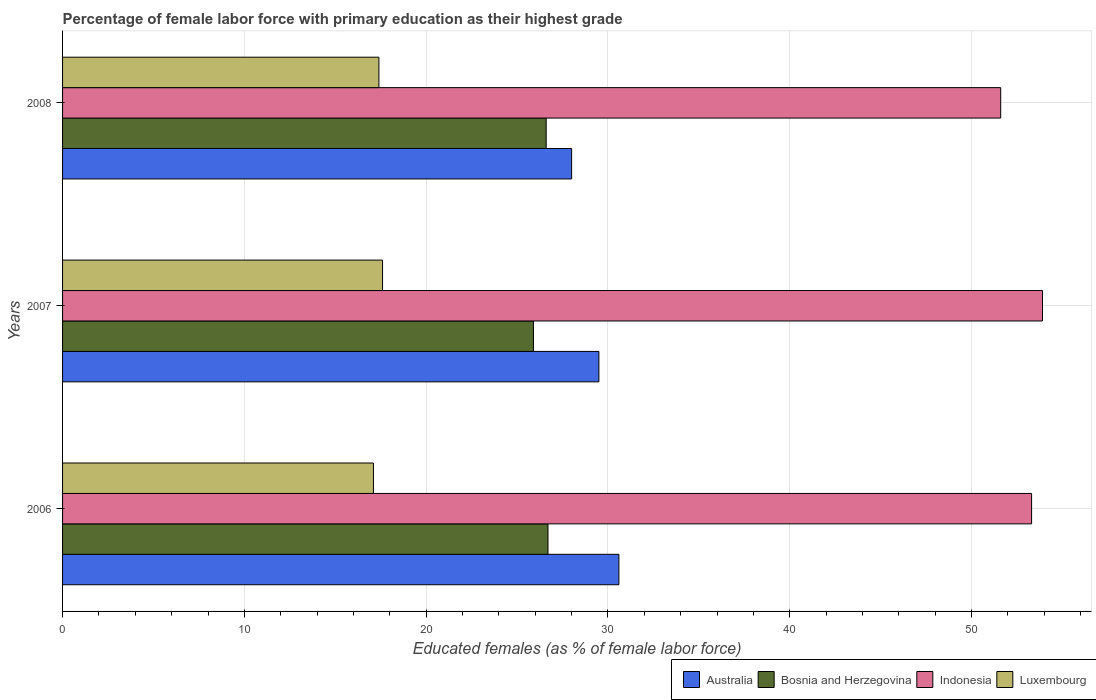How many groups of bars are there?
Ensure brevity in your answer.  3. Are the number of bars on each tick of the Y-axis equal?
Your answer should be compact. Yes. How many bars are there on the 1st tick from the top?
Your answer should be compact. 4. What is the label of the 1st group of bars from the top?
Offer a terse response. 2008. What is the percentage of female labor force with primary education in Indonesia in 2006?
Keep it short and to the point. 53.3. Across all years, what is the maximum percentage of female labor force with primary education in Australia?
Your answer should be very brief. 30.6. Across all years, what is the minimum percentage of female labor force with primary education in Bosnia and Herzegovina?
Give a very brief answer. 25.9. What is the total percentage of female labor force with primary education in Luxembourg in the graph?
Provide a short and direct response. 52.1. What is the difference between the percentage of female labor force with primary education in Luxembourg in 2006 and the percentage of female labor force with primary education in Bosnia and Herzegovina in 2007?
Offer a very short reply. -8.8. What is the average percentage of female labor force with primary education in Bosnia and Herzegovina per year?
Provide a succinct answer. 26.4. In the year 2007, what is the difference between the percentage of female labor force with primary education in Indonesia and percentage of female labor force with primary education in Bosnia and Herzegovina?
Give a very brief answer. 28. In how many years, is the percentage of female labor force with primary education in Bosnia and Herzegovina greater than 10 %?
Provide a succinct answer. 3. What is the ratio of the percentage of female labor force with primary education in Indonesia in 2006 to that in 2008?
Ensure brevity in your answer.  1.03. Is the difference between the percentage of female labor force with primary education in Indonesia in 2006 and 2008 greater than the difference between the percentage of female labor force with primary education in Bosnia and Herzegovina in 2006 and 2008?
Your answer should be very brief. Yes. What is the difference between the highest and the second highest percentage of female labor force with primary education in Bosnia and Herzegovina?
Your answer should be compact. 0.1. What is the difference between the highest and the lowest percentage of female labor force with primary education in Indonesia?
Provide a succinct answer. 2.3. Is it the case that in every year, the sum of the percentage of female labor force with primary education in Luxembourg and percentage of female labor force with primary education in Australia is greater than the sum of percentage of female labor force with primary education in Bosnia and Herzegovina and percentage of female labor force with primary education in Indonesia?
Offer a very short reply. No. What does the 2nd bar from the top in 2006 represents?
Ensure brevity in your answer.  Indonesia. What does the 2nd bar from the bottom in 2007 represents?
Keep it short and to the point. Bosnia and Herzegovina. Are all the bars in the graph horizontal?
Provide a succinct answer. Yes. How many years are there in the graph?
Ensure brevity in your answer.  3. What is the difference between two consecutive major ticks on the X-axis?
Your answer should be very brief. 10. Does the graph contain any zero values?
Offer a terse response. No. How many legend labels are there?
Ensure brevity in your answer.  4. How are the legend labels stacked?
Provide a succinct answer. Horizontal. What is the title of the graph?
Offer a very short reply. Percentage of female labor force with primary education as their highest grade. What is the label or title of the X-axis?
Your answer should be very brief. Educated females (as % of female labor force). What is the label or title of the Y-axis?
Your answer should be very brief. Years. What is the Educated females (as % of female labor force) of Australia in 2006?
Ensure brevity in your answer.  30.6. What is the Educated females (as % of female labor force) in Bosnia and Herzegovina in 2006?
Provide a succinct answer. 26.7. What is the Educated females (as % of female labor force) in Indonesia in 2006?
Offer a terse response. 53.3. What is the Educated females (as % of female labor force) of Luxembourg in 2006?
Keep it short and to the point. 17.1. What is the Educated females (as % of female labor force) in Australia in 2007?
Make the answer very short. 29.5. What is the Educated females (as % of female labor force) of Bosnia and Herzegovina in 2007?
Give a very brief answer. 25.9. What is the Educated females (as % of female labor force) of Indonesia in 2007?
Keep it short and to the point. 53.9. What is the Educated females (as % of female labor force) in Luxembourg in 2007?
Provide a succinct answer. 17.6. What is the Educated females (as % of female labor force) in Bosnia and Herzegovina in 2008?
Provide a short and direct response. 26.6. What is the Educated females (as % of female labor force) of Indonesia in 2008?
Keep it short and to the point. 51.6. What is the Educated females (as % of female labor force) in Luxembourg in 2008?
Your response must be concise. 17.4. Across all years, what is the maximum Educated females (as % of female labor force) of Australia?
Provide a succinct answer. 30.6. Across all years, what is the maximum Educated females (as % of female labor force) of Bosnia and Herzegovina?
Provide a succinct answer. 26.7. Across all years, what is the maximum Educated females (as % of female labor force) in Indonesia?
Ensure brevity in your answer.  53.9. Across all years, what is the maximum Educated females (as % of female labor force) of Luxembourg?
Offer a very short reply. 17.6. Across all years, what is the minimum Educated females (as % of female labor force) of Bosnia and Herzegovina?
Give a very brief answer. 25.9. Across all years, what is the minimum Educated females (as % of female labor force) of Indonesia?
Give a very brief answer. 51.6. Across all years, what is the minimum Educated females (as % of female labor force) in Luxembourg?
Ensure brevity in your answer.  17.1. What is the total Educated females (as % of female labor force) in Australia in the graph?
Offer a very short reply. 88.1. What is the total Educated females (as % of female labor force) of Bosnia and Herzegovina in the graph?
Provide a succinct answer. 79.2. What is the total Educated females (as % of female labor force) in Indonesia in the graph?
Provide a short and direct response. 158.8. What is the total Educated females (as % of female labor force) in Luxembourg in the graph?
Provide a succinct answer. 52.1. What is the difference between the Educated females (as % of female labor force) in Australia in 2006 and that in 2007?
Your answer should be very brief. 1.1. What is the difference between the Educated females (as % of female labor force) in Luxembourg in 2006 and that in 2007?
Your response must be concise. -0.5. What is the difference between the Educated females (as % of female labor force) in Luxembourg in 2006 and that in 2008?
Your answer should be very brief. -0.3. What is the difference between the Educated females (as % of female labor force) in Bosnia and Herzegovina in 2007 and that in 2008?
Your answer should be very brief. -0.7. What is the difference between the Educated females (as % of female labor force) in Indonesia in 2007 and that in 2008?
Ensure brevity in your answer.  2.3. What is the difference between the Educated females (as % of female labor force) in Luxembourg in 2007 and that in 2008?
Offer a very short reply. 0.2. What is the difference between the Educated females (as % of female labor force) of Australia in 2006 and the Educated females (as % of female labor force) of Bosnia and Herzegovina in 2007?
Your response must be concise. 4.7. What is the difference between the Educated females (as % of female labor force) of Australia in 2006 and the Educated females (as % of female labor force) of Indonesia in 2007?
Keep it short and to the point. -23.3. What is the difference between the Educated females (as % of female labor force) in Bosnia and Herzegovina in 2006 and the Educated females (as % of female labor force) in Indonesia in 2007?
Give a very brief answer. -27.2. What is the difference between the Educated females (as % of female labor force) in Bosnia and Herzegovina in 2006 and the Educated females (as % of female labor force) in Luxembourg in 2007?
Provide a short and direct response. 9.1. What is the difference between the Educated females (as % of female labor force) in Indonesia in 2006 and the Educated females (as % of female labor force) in Luxembourg in 2007?
Give a very brief answer. 35.7. What is the difference between the Educated females (as % of female labor force) in Australia in 2006 and the Educated females (as % of female labor force) in Bosnia and Herzegovina in 2008?
Your answer should be compact. 4. What is the difference between the Educated females (as % of female labor force) in Australia in 2006 and the Educated females (as % of female labor force) in Luxembourg in 2008?
Ensure brevity in your answer.  13.2. What is the difference between the Educated females (as % of female labor force) in Bosnia and Herzegovina in 2006 and the Educated females (as % of female labor force) in Indonesia in 2008?
Offer a very short reply. -24.9. What is the difference between the Educated females (as % of female labor force) in Indonesia in 2006 and the Educated females (as % of female labor force) in Luxembourg in 2008?
Offer a terse response. 35.9. What is the difference between the Educated females (as % of female labor force) in Australia in 2007 and the Educated females (as % of female labor force) in Indonesia in 2008?
Keep it short and to the point. -22.1. What is the difference between the Educated females (as % of female labor force) of Bosnia and Herzegovina in 2007 and the Educated females (as % of female labor force) of Indonesia in 2008?
Your answer should be very brief. -25.7. What is the difference between the Educated females (as % of female labor force) of Indonesia in 2007 and the Educated females (as % of female labor force) of Luxembourg in 2008?
Keep it short and to the point. 36.5. What is the average Educated females (as % of female labor force) of Australia per year?
Offer a very short reply. 29.37. What is the average Educated females (as % of female labor force) of Bosnia and Herzegovina per year?
Your answer should be very brief. 26.4. What is the average Educated females (as % of female labor force) in Indonesia per year?
Make the answer very short. 52.93. What is the average Educated females (as % of female labor force) in Luxembourg per year?
Your response must be concise. 17.37. In the year 2006, what is the difference between the Educated females (as % of female labor force) in Australia and Educated females (as % of female labor force) in Indonesia?
Give a very brief answer. -22.7. In the year 2006, what is the difference between the Educated females (as % of female labor force) in Australia and Educated females (as % of female labor force) in Luxembourg?
Ensure brevity in your answer.  13.5. In the year 2006, what is the difference between the Educated females (as % of female labor force) in Bosnia and Herzegovina and Educated females (as % of female labor force) in Indonesia?
Provide a succinct answer. -26.6. In the year 2006, what is the difference between the Educated females (as % of female labor force) of Bosnia and Herzegovina and Educated females (as % of female labor force) of Luxembourg?
Provide a succinct answer. 9.6. In the year 2006, what is the difference between the Educated females (as % of female labor force) in Indonesia and Educated females (as % of female labor force) in Luxembourg?
Give a very brief answer. 36.2. In the year 2007, what is the difference between the Educated females (as % of female labor force) of Australia and Educated females (as % of female labor force) of Indonesia?
Give a very brief answer. -24.4. In the year 2007, what is the difference between the Educated females (as % of female labor force) in Bosnia and Herzegovina and Educated females (as % of female labor force) in Indonesia?
Your answer should be compact. -28. In the year 2007, what is the difference between the Educated females (as % of female labor force) in Bosnia and Herzegovina and Educated females (as % of female labor force) in Luxembourg?
Make the answer very short. 8.3. In the year 2007, what is the difference between the Educated females (as % of female labor force) in Indonesia and Educated females (as % of female labor force) in Luxembourg?
Your answer should be very brief. 36.3. In the year 2008, what is the difference between the Educated females (as % of female labor force) in Australia and Educated females (as % of female labor force) in Bosnia and Herzegovina?
Give a very brief answer. 1.4. In the year 2008, what is the difference between the Educated females (as % of female labor force) of Australia and Educated females (as % of female labor force) of Indonesia?
Keep it short and to the point. -23.6. In the year 2008, what is the difference between the Educated females (as % of female labor force) of Indonesia and Educated females (as % of female labor force) of Luxembourg?
Keep it short and to the point. 34.2. What is the ratio of the Educated females (as % of female labor force) of Australia in 2006 to that in 2007?
Keep it short and to the point. 1.04. What is the ratio of the Educated females (as % of female labor force) in Bosnia and Herzegovina in 2006 to that in 2007?
Ensure brevity in your answer.  1.03. What is the ratio of the Educated females (as % of female labor force) in Indonesia in 2006 to that in 2007?
Your response must be concise. 0.99. What is the ratio of the Educated females (as % of female labor force) of Luxembourg in 2006 to that in 2007?
Your answer should be compact. 0.97. What is the ratio of the Educated females (as % of female labor force) of Australia in 2006 to that in 2008?
Keep it short and to the point. 1.09. What is the ratio of the Educated females (as % of female labor force) in Indonesia in 2006 to that in 2008?
Provide a short and direct response. 1.03. What is the ratio of the Educated females (as % of female labor force) of Luxembourg in 2006 to that in 2008?
Provide a short and direct response. 0.98. What is the ratio of the Educated females (as % of female labor force) in Australia in 2007 to that in 2008?
Keep it short and to the point. 1.05. What is the ratio of the Educated females (as % of female labor force) of Bosnia and Herzegovina in 2007 to that in 2008?
Provide a succinct answer. 0.97. What is the ratio of the Educated females (as % of female labor force) in Indonesia in 2007 to that in 2008?
Keep it short and to the point. 1.04. What is the ratio of the Educated females (as % of female labor force) of Luxembourg in 2007 to that in 2008?
Offer a very short reply. 1.01. What is the difference between the highest and the second highest Educated females (as % of female labor force) of Australia?
Your answer should be compact. 1.1. What is the difference between the highest and the lowest Educated females (as % of female labor force) in Bosnia and Herzegovina?
Your answer should be very brief. 0.8. What is the difference between the highest and the lowest Educated females (as % of female labor force) in Indonesia?
Offer a terse response. 2.3. What is the difference between the highest and the lowest Educated females (as % of female labor force) of Luxembourg?
Provide a short and direct response. 0.5. 